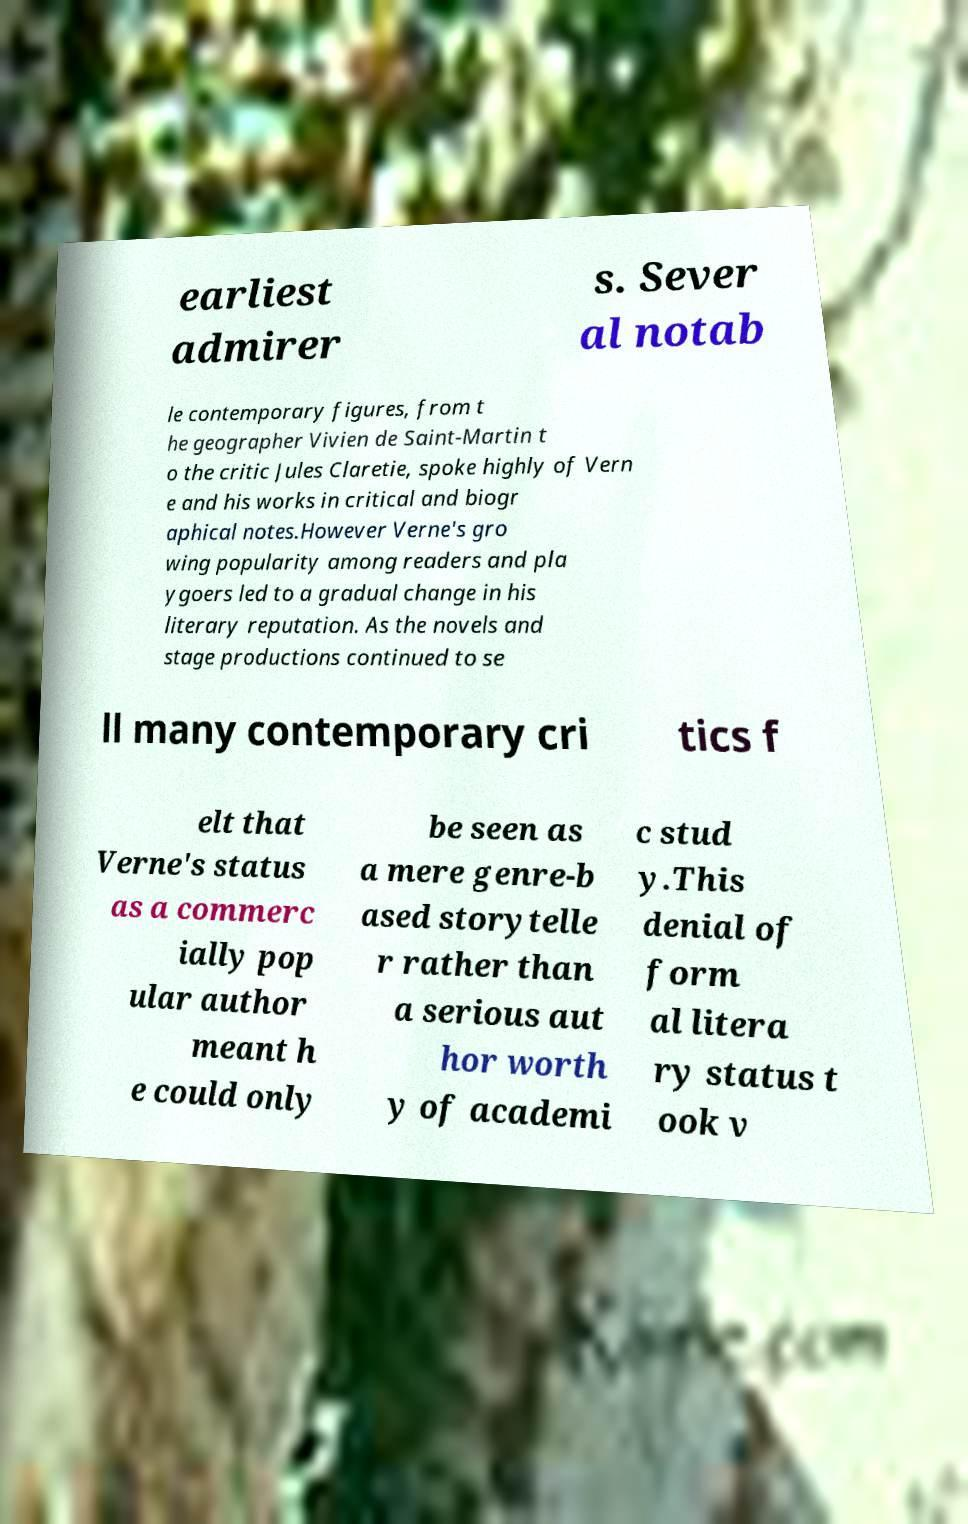Can you read and provide the text displayed in the image?This photo seems to have some interesting text. Can you extract and type it out for me? earliest admirer s. Sever al notab le contemporary figures, from t he geographer Vivien de Saint-Martin t o the critic Jules Claretie, spoke highly of Vern e and his works in critical and biogr aphical notes.However Verne's gro wing popularity among readers and pla ygoers led to a gradual change in his literary reputation. As the novels and stage productions continued to se ll many contemporary cri tics f elt that Verne's status as a commerc ially pop ular author meant h e could only be seen as a mere genre-b ased storytelle r rather than a serious aut hor worth y of academi c stud y.This denial of form al litera ry status t ook v 